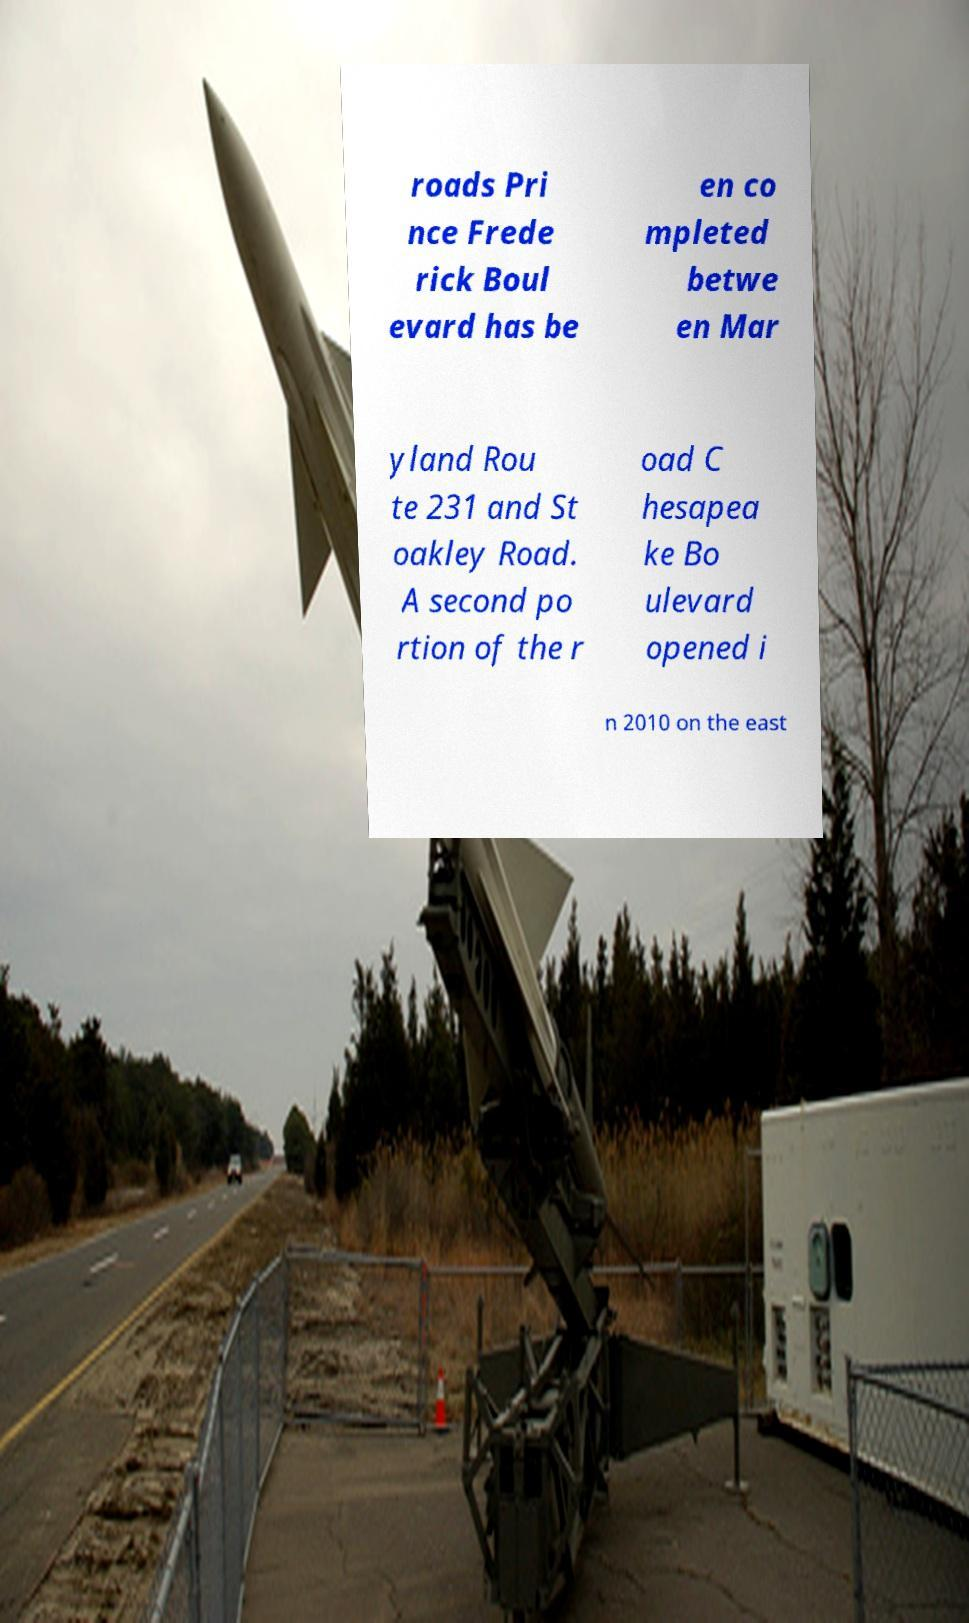Could you extract and type out the text from this image? roads Pri nce Frede rick Boul evard has be en co mpleted betwe en Mar yland Rou te 231 and St oakley Road. A second po rtion of the r oad C hesapea ke Bo ulevard opened i n 2010 on the east 